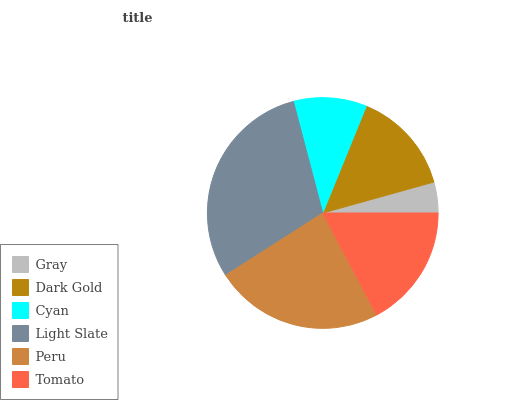Is Gray the minimum?
Answer yes or no. Yes. Is Light Slate the maximum?
Answer yes or no. Yes. Is Dark Gold the minimum?
Answer yes or no. No. Is Dark Gold the maximum?
Answer yes or no. No. Is Dark Gold greater than Gray?
Answer yes or no. Yes. Is Gray less than Dark Gold?
Answer yes or no. Yes. Is Gray greater than Dark Gold?
Answer yes or no. No. Is Dark Gold less than Gray?
Answer yes or no. No. Is Tomato the high median?
Answer yes or no. Yes. Is Dark Gold the low median?
Answer yes or no. Yes. Is Cyan the high median?
Answer yes or no. No. Is Tomato the low median?
Answer yes or no. No. 